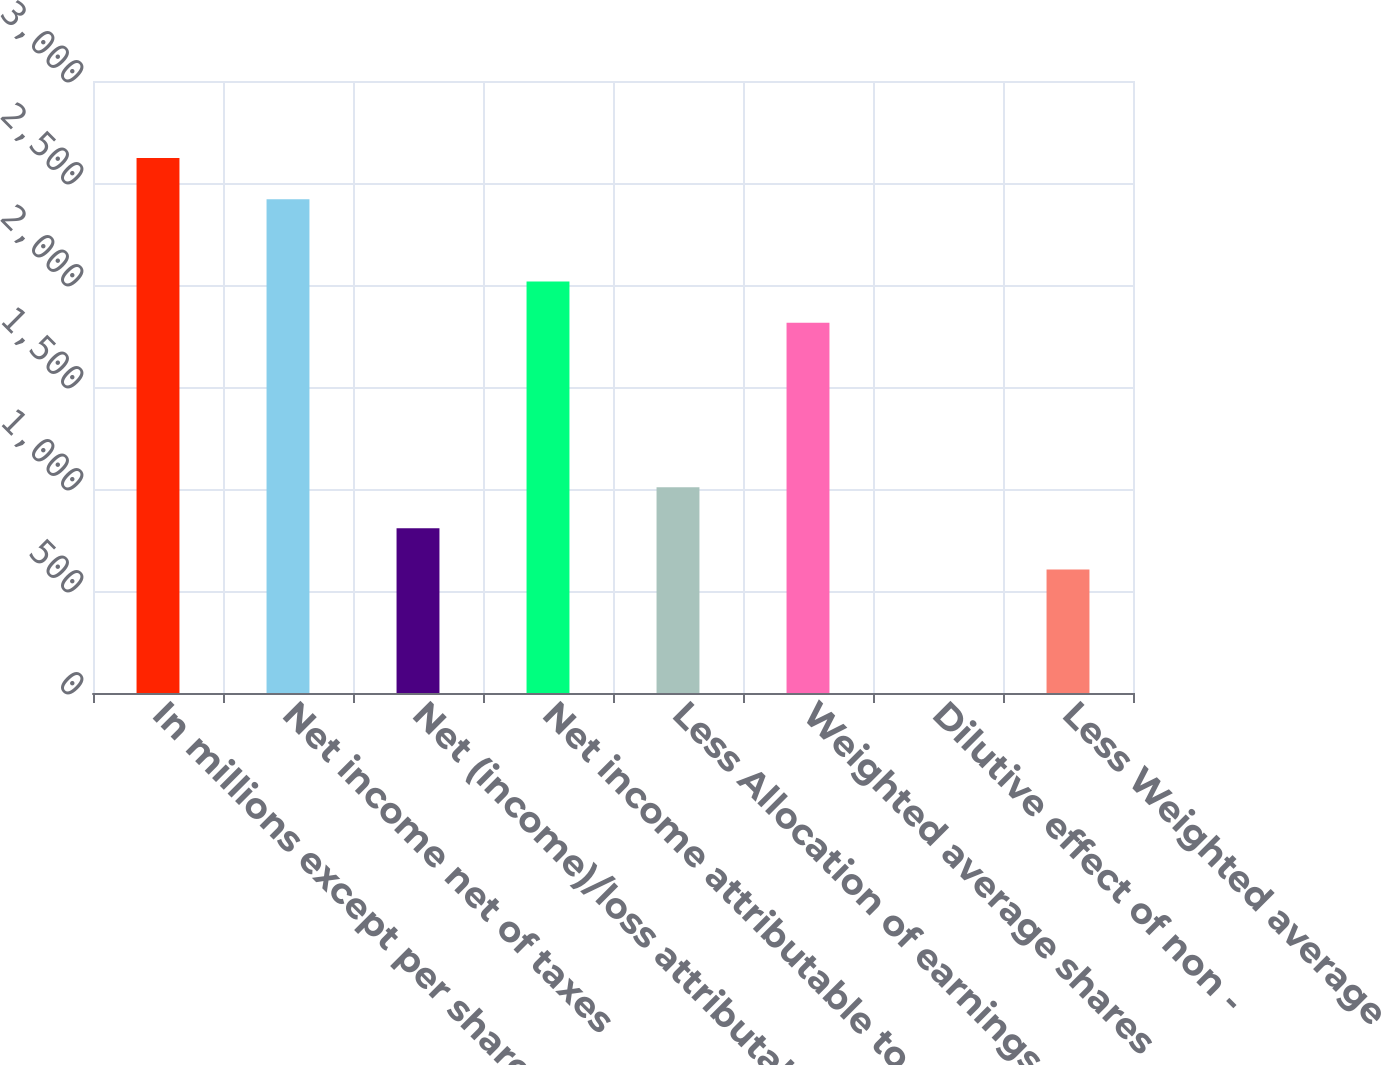<chart> <loc_0><loc_0><loc_500><loc_500><bar_chart><fcel>In millions except per share<fcel>Net income net of taxes<fcel>Net (income)/loss attributable<fcel>Net income attributable to<fcel>Less Allocation of earnings to<fcel>Weighted average shares<fcel>Dilutive effect of non -<fcel>Less Weighted average<nl><fcel>2621.95<fcel>2420.3<fcel>807.1<fcel>2017<fcel>1008.75<fcel>1815.35<fcel>0.5<fcel>605.45<nl></chart> 